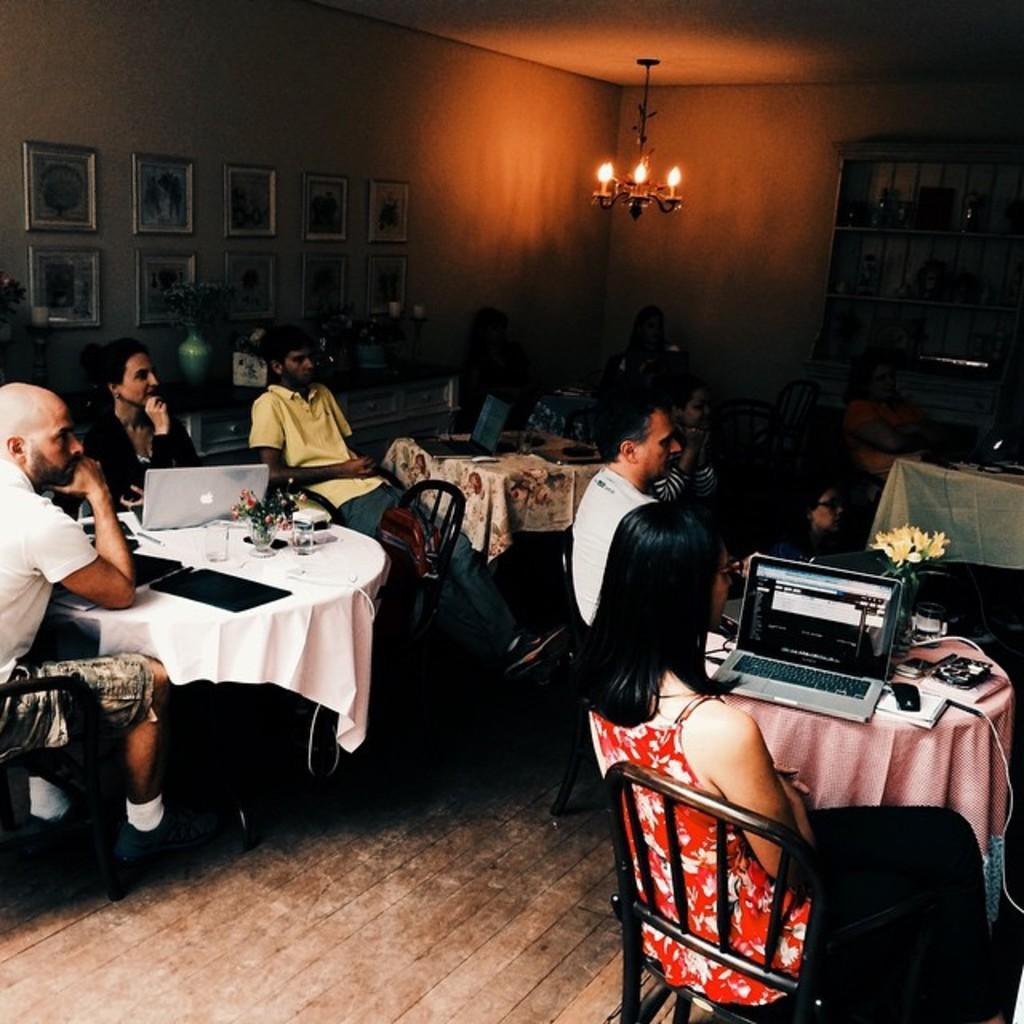Can you describe this image briefly? In this image I can see number of people are sitting on chairs. I can also see laptop on tables. In the background I can see few frames on this wall. 